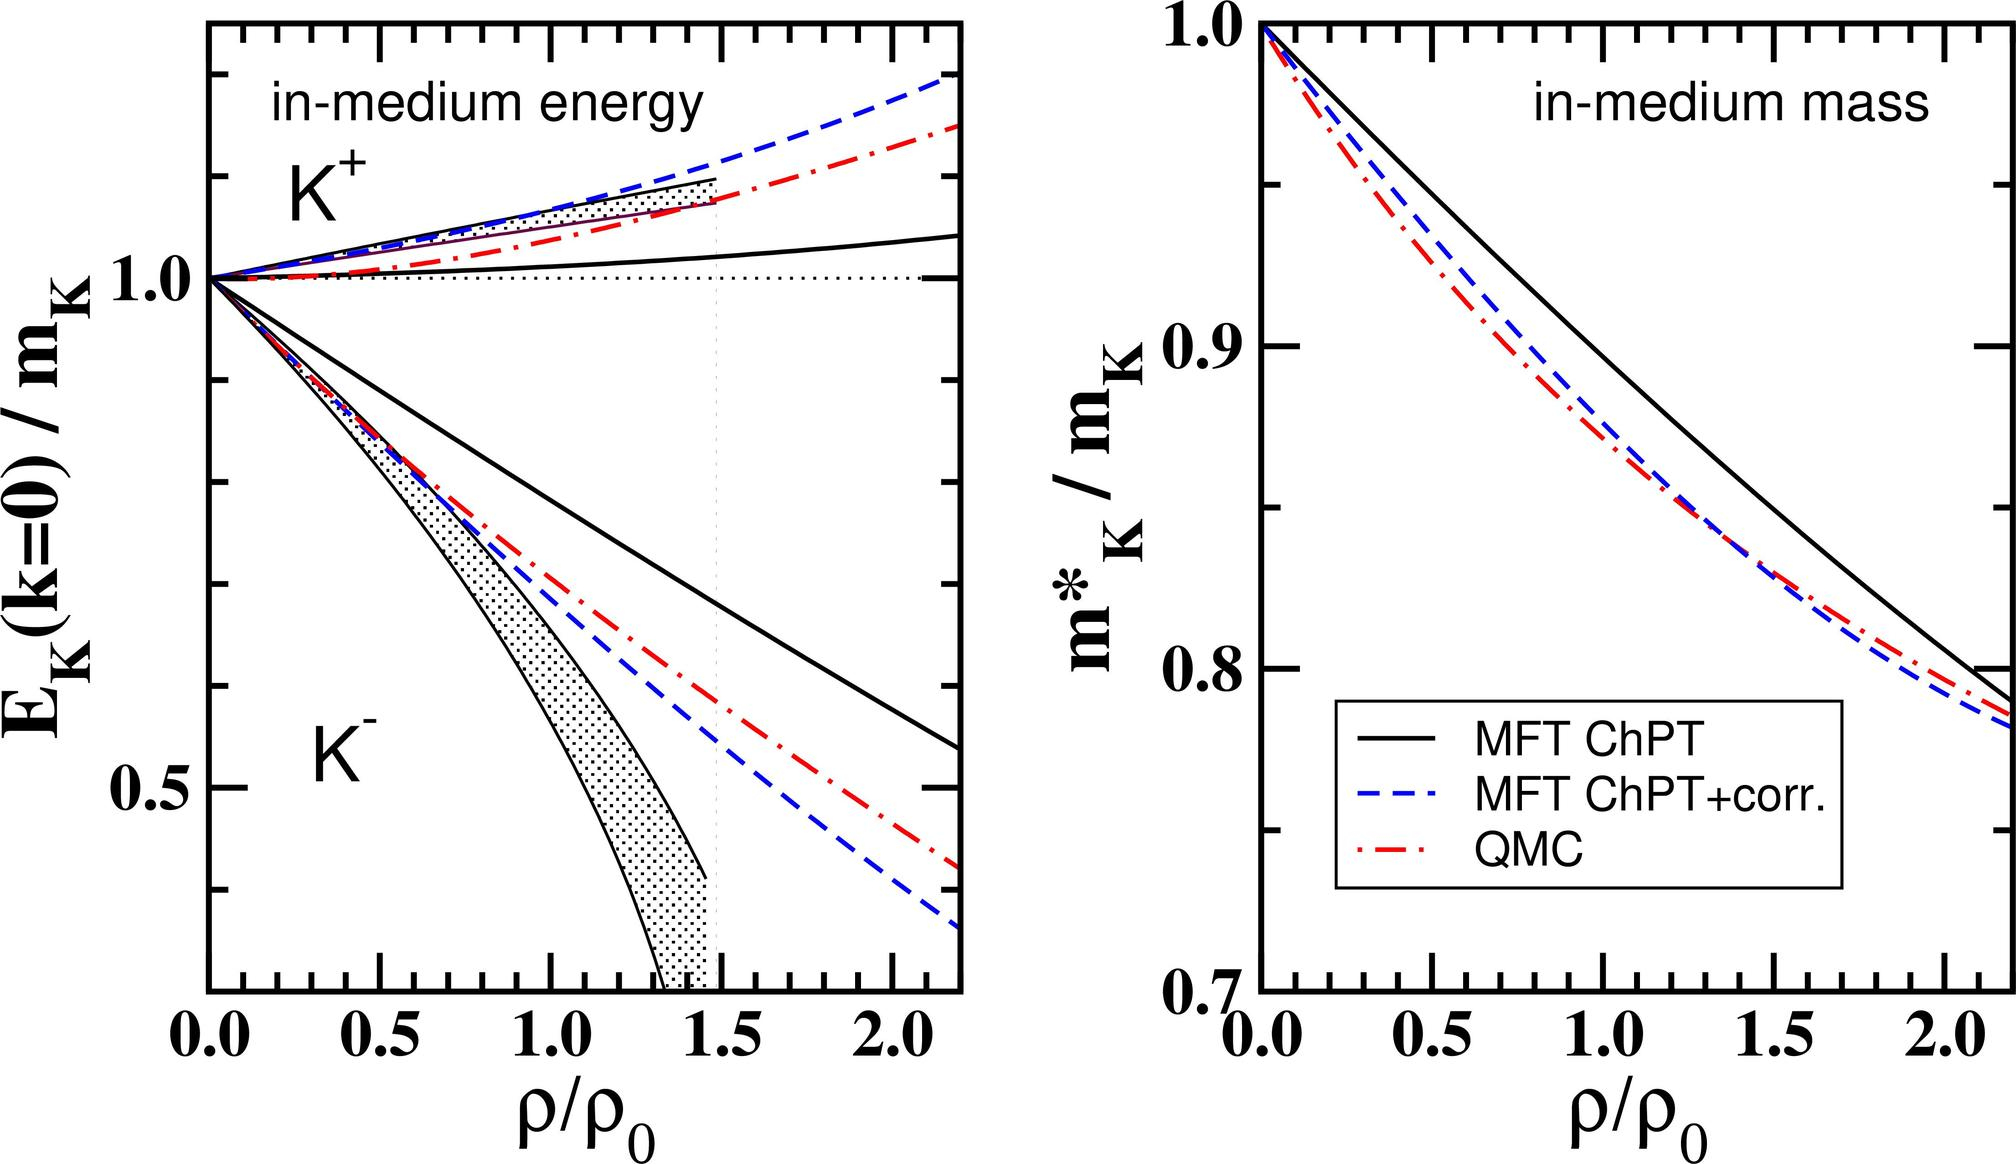Can you explain why the QMC model predicts a greater decrease in the \( K^+ \) meson mass compared to MFT ChPT at increasing nuclear densities? The Quark-Meson Coupling (QMC) model, represented by the red dashed line on the right graph, shows a steeper decline in the in-medium mass of the \( K^+ \) meson as nuclear density increases compared to MFT ChPT (solid black line). This is due to the QMC model's inclusion of the quark degrees of freedom within nucleons affecting the meson fields. At higher densities, these effects are more pronounced, leading to a greater effective mass reduction of the \( K^+ \) meson, illustrating the different theoretical implications of quark interactions in a dense nuclear medium. 